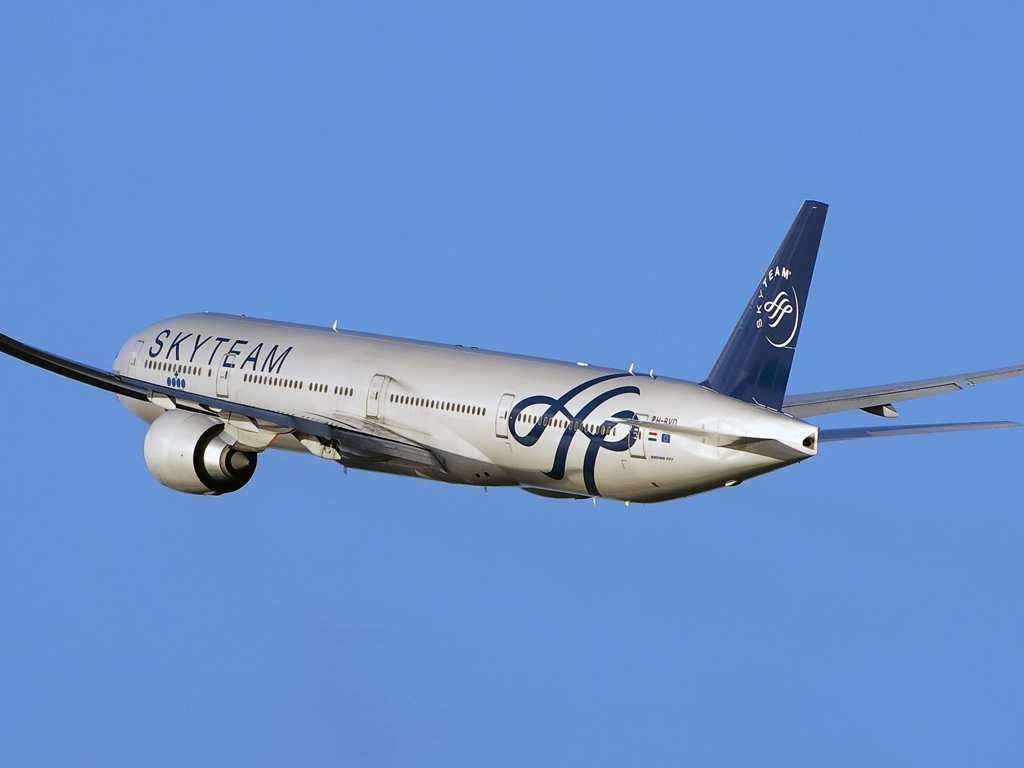Describe the time of day and weather conditions that might be suggested by the lighting and sky in the image. The lighting in the image suggests that it was taken during the day under clear weather conditions. The sky is a vivid blue with no visible clouds, indicating that it is possibly midday or early afternoon when the sun is bright and high, providing excellent visibility for both the photographer and the aircraft. 